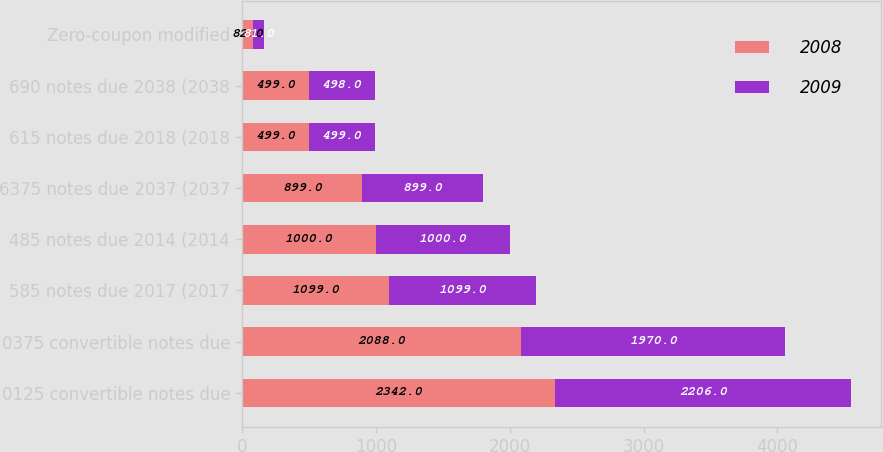Convert chart to OTSL. <chart><loc_0><loc_0><loc_500><loc_500><stacked_bar_chart><ecel><fcel>0125 convertible notes due<fcel>0375 convertible notes due<fcel>585 notes due 2017 (2017<fcel>485 notes due 2014 (2014<fcel>6375 notes due 2037 (2037<fcel>615 notes due 2018 (2018<fcel>690 notes due 2038 (2038<fcel>Zero-coupon modified<nl><fcel>2008<fcel>2342<fcel>2088<fcel>1099<fcel>1000<fcel>899<fcel>499<fcel>499<fcel>82<nl><fcel>2009<fcel>2206<fcel>1970<fcel>1099<fcel>1000<fcel>899<fcel>499<fcel>498<fcel>81<nl></chart> 